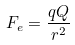Convert formula to latex. <formula><loc_0><loc_0><loc_500><loc_500>F _ { e } = \frac { q Q } { r ^ { 2 } }</formula> 